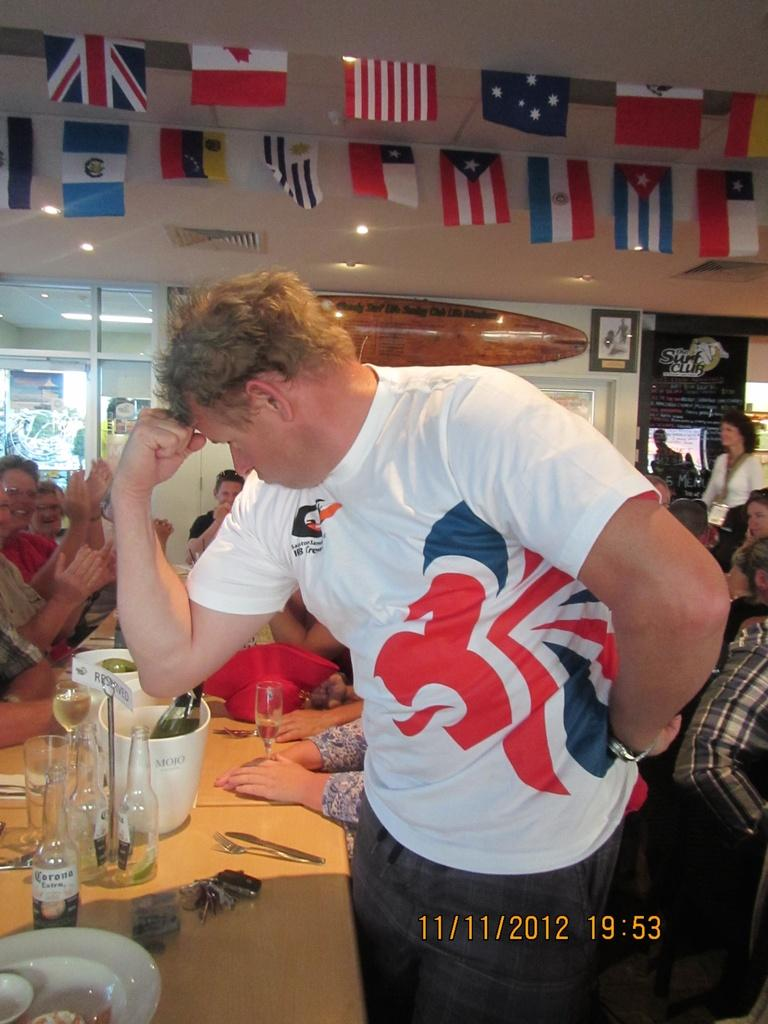<image>
Describe the image concisely. A man posing with his hand on his forehead while standing near a table with bottles of Corona Extra and Mojo bowls on it. 